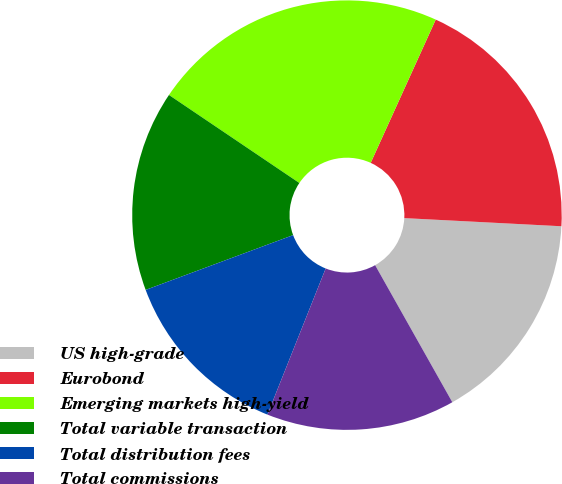Convert chart. <chart><loc_0><loc_0><loc_500><loc_500><pie_chart><fcel>US high-grade<fcel>Eurobond<fcel>Emerging markets high-yield<fcel>Total variable transaction<fcel>Total distribution fees<fcel>Total commissions<nl><fcel>16.01%<fcel>19.04%<fcel>22.33%<fcel>15.11%<fcel>13.3%<fcel>14.2%<nl></chart> 